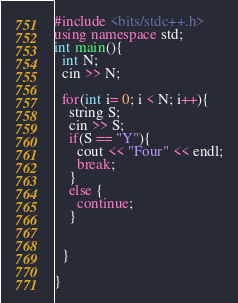Convert code to text. <code><loc_0><loc_0><loc_500><loc_500><_C++_>#include <bits/stdc++.h>
using namespace std;
int main(){
  int N;
  cin >> N;
  
  for(int i= 0; i < N; i++){
    string S;
    cin >> S;
    if(S == "Y"){
      cout << "Four" << endl;
      break;
    }
    else {
      continue;
    }
    
    
  }

}</code> 